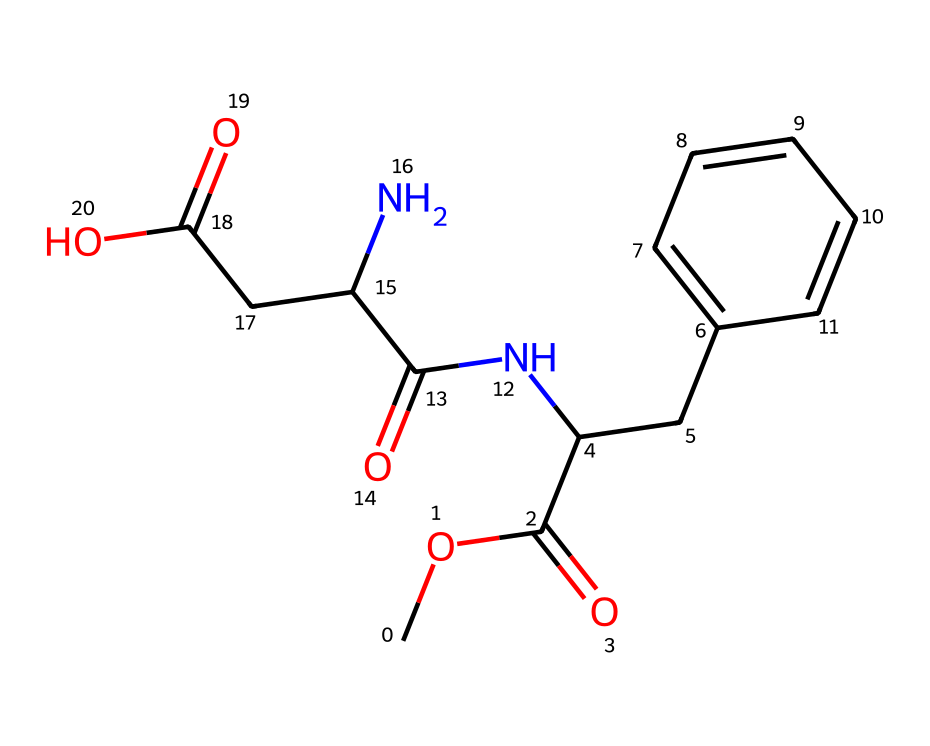What is the molecular formula of aspartame? To find the molecular formula, count the number of each type of atom present in the SMILES representation. There are 14 carbon atoms, 18 hydrogen atoms, 2 nitrogen atoms, and 4 oxygen atoms. This gives the formula C14H18N2O4.
Answer: C14H18N2O4 How many distinct rings are present in the structure of aspartame? By analyzing the SMILES, the cyclohexene ring system can be identified in the side chain (indicated by CC1=CC=CC=C1). There is one ring in total that contains six carbon atoms.
Answer: 1 What is the functional group indicated by "C(=O)" in the structure? The "C(=O)" denotes a carbonyl group, specifically a ketone or an ester, depending on its location in the molecular structure. In this case, it appears in the context of the amide and ester functional groups.
Answer: carbonyl What type of chemical is aspartame categorized as? Aspertame is an artificial sweetener, which is a common category for compounds designed to produce a sweetness effect without significant calories. The presence of amine and ester functional groups also supports this classification.
Answer: artificial sweetener How many nitrogen atoms are present in the aspartame molecule? The nitrogen atoms can be counted directly from the SMILES, where "N" appears twice. This indicates that there are exactly two nitrogen atoms in the structure of aspartame.
Answer: 2 What contribution does the ester group make to aspartame’s sweetness? The ester group (indicated by C(=O)OC) is known to enhance sweetness perception and stability, contributing to the overall sweet taste of aspartame by modifying how taste receptors respond.
Answer: enhances sweetness 